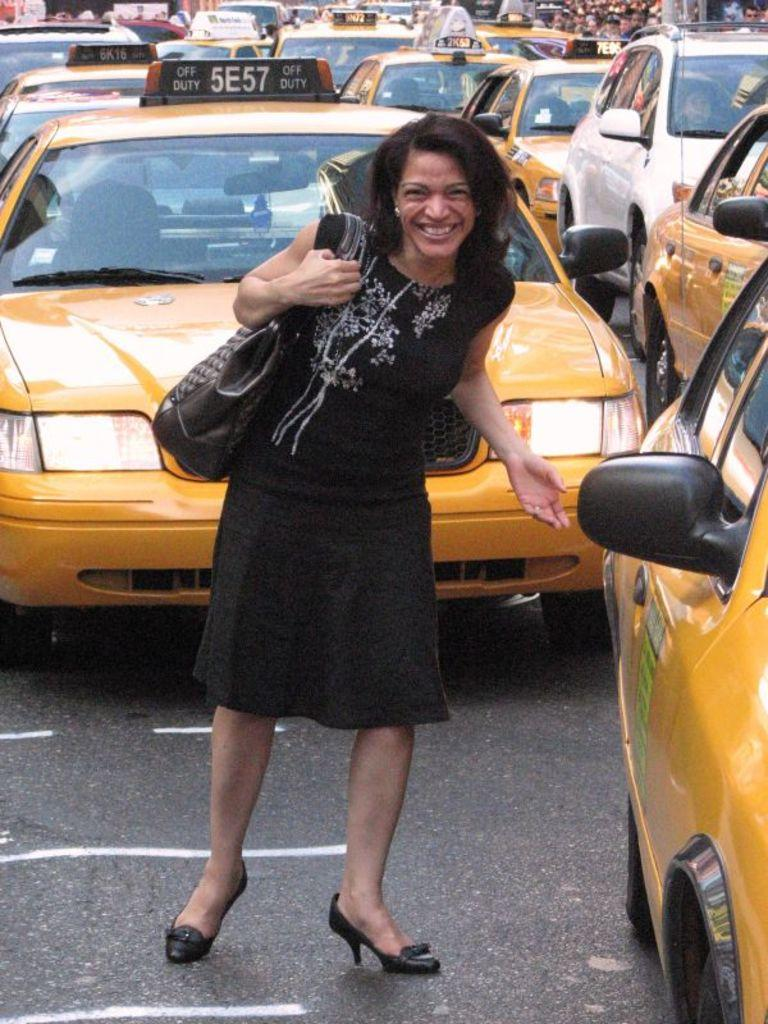<image>
Offer a succinct explanation of the picture presented. a lady getting in a taxi next to 5E57 